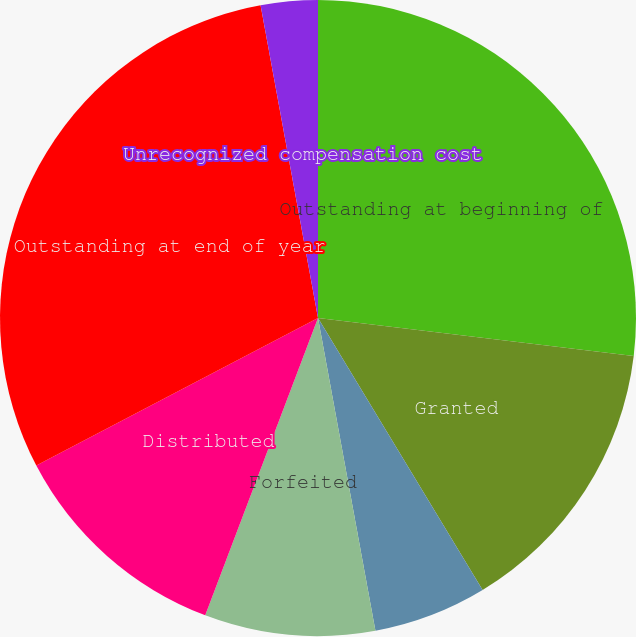Convert chart to OTSL. <chart><loc_0><loc_0><loc_500><loc_500><pie_chart><fcel>Outstanding at beginning of<fcel>Granted<fcel>Dividends<fcel>Forfeited<fcel>Distributed<fcel>Outstanding at end of year<fcel>Unrecognized compensation cost<fcel>Weighted average remaining<nl><fcel>26.91%<fcel>14.43%<fcel>5.77%<fcel>8.66%<fcel>11.55%<fcel>29.79%<fcel>2.89%<fcel>0.0%<nl></chart> 